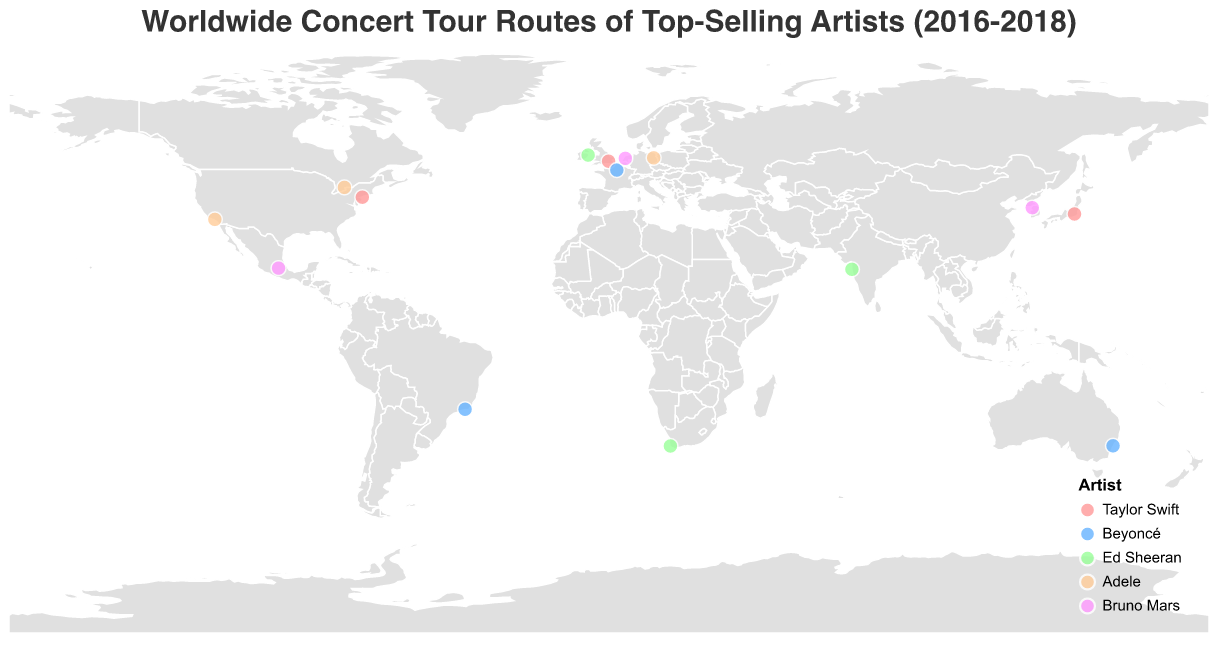What's the title of the geographic plot? The title is located at the top of the plot and provides a summary of the figure's purpose. It reads "Worldwide Concert Tour Routes of Top-Selling Artists (2016-2018)."
Answer: "Worldwide Concert Tour Routes of Top-Selling Artists (2016-2018)" What color represents Taylor Swift's concert locations on the map? Refer to the legend in the bottom-right of the plot to determine the color associated with Taylor Swift. According to the legend, her locations are marked in a pink shade.
Answer: Pink How many cities did Beyoncé perform in according to the plot? Identify the data points associated with Beyoncé by matching the light blue color in the plot. Count the total number of distinct cities shown. There are three cities where Beyoncé performed.
Answer: 3 Which artist performed in Tokyo, Japan, and in what year? Hover over the data point at the coordinates corresponding to Tokyo (Latitude: 35.6762, Longitude: 139.6503) to see the tooltip. The tooltip identifies Taylor Swift as the artist who performed there in 2018.
Answer: Taylor Swift, 2018 Which artist had the most geographically diverse tour based on the number of unique countries? Count the distinct countries that each artist toured using the geographic distribution of their respective colored data points. Beyoncé performed in France, Australia, and Brazil, covering three unique countries, whereas other artists covered fewer countries.
Answer: Beyoncé Which city was visited by Ed Sheeran in 2017 that is located in South Africa? Locate Ed Sheeran's data points by referring to the legend and identifying the #99ff99 green markers. Find the green marker in South Africa, which is at Cape Town (Latitude: -33.9249, Longitude: 18.4241), and refer to the tooltip to confirm the year was 2017.
Answer: Cape Town Did Bruno Mars perform in more or fewer cities than Adele according to the plot? Compare the number of unique data points for Bruno Mars and Adele. Bruno Mars performed in Seoul, Mexico City, and Amsterdam (3 cities). Adele performed in Los Angeles, Berlin, and Toronto (3 cities).
Answer: Equal Identify all countries that hosted at least one concert by Taylor Swift. By spotting the pink-colored data points, observe the countries these points are in: United States, United Kingdom, and Japan.
Answer: United States, United Kingdom, Japan Which artist's tour included a visit to Dublin, and in what year? Find the data point marked in orange (Ed Sheeran) at the coordinates for Dublin (Latitude: 53.3498, Longitude: -6.2603). The tooltip reveals that Ed Sheeran visited Dublin in 2017.
Answer: Ed Sheeran, 2017 